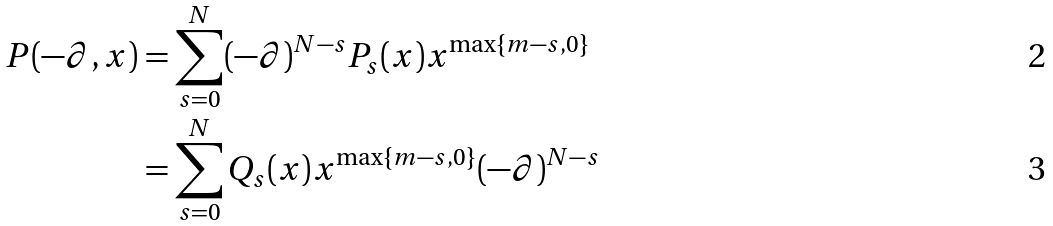<formula> <loc_0><loc_0><loc_500><loc_500>P ( - \partial , x ) & = \sum _ { s = 0 } ^ { N } ( - \partial ) ^ { N - s } P _ { s } ( x ) x ^ { \max \{ m - s , 0 \} } \\ & = \sum _ { s = 0 } ^ { N } Q _ { s } ( x ) x ^ { \max \{ m - s , 0 \} } ( - \partial ) ^ { N - s }</formula> 